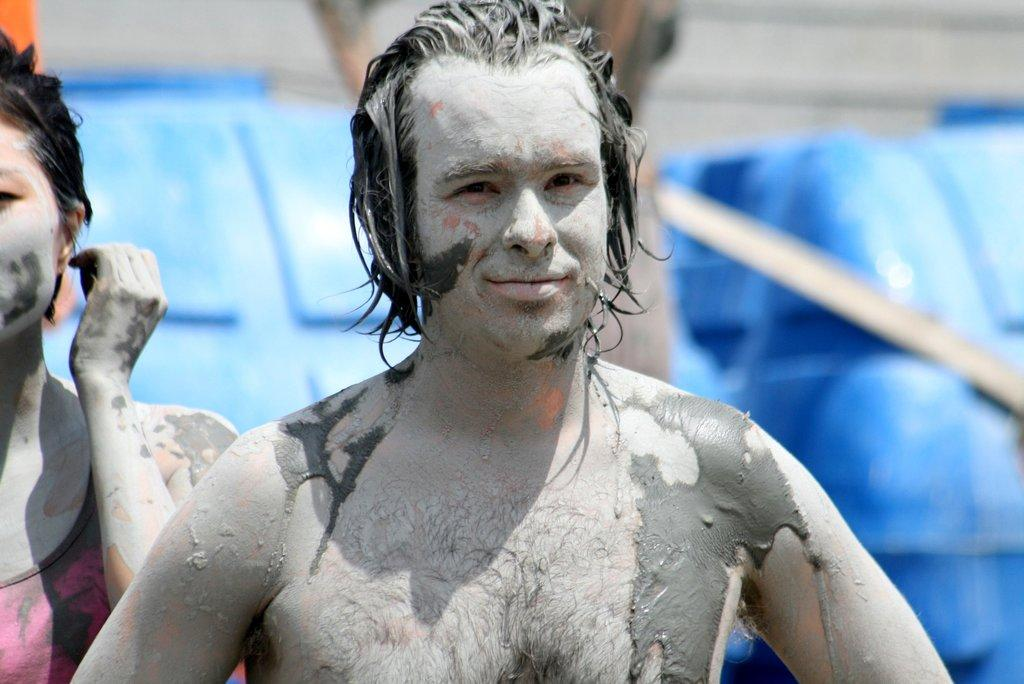How many people are present in the image? There are two people standing in the image. What is the condition of their bodies? Mud is visible on their bodies. Can you describe the background of the image? The background of the image is blurry. What type of popcorn is being served in the image? There is no popcorn present in the image. How do the people feel about being covered in mud in the image? We cannot determine how the people feel about being covered in mud from the image alone, as emotions are not visible. 